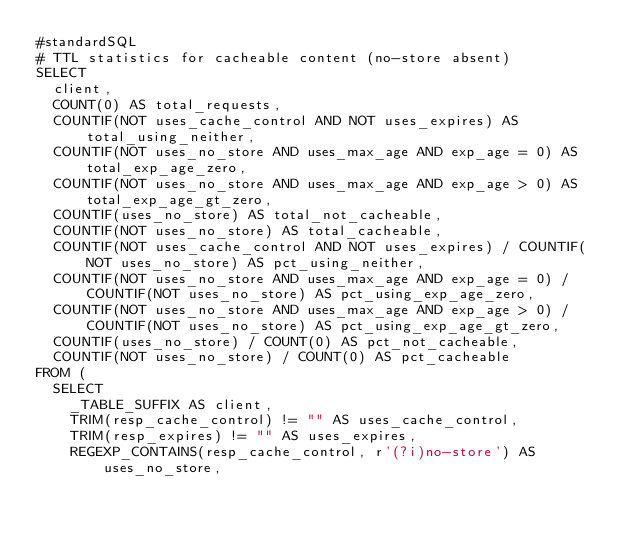<code> <loc_0><loc_0><loc_500><loc_500><_SQL_>#standardSQL
# TTL statistics for cacheable content (no-store absent)
SELECT
  client,
  COUNT(0) AS total_requests,
  COUNTIF(NOT uses_cache_control AND NOT uses_expires) AS total_using_neither,
  COUNTIF(NOT uses_no_store AND uses_max_age AND exp_age = 0) AS total_exp_age_zero,
  COUNTIF(NOT uses_no_store AND uses_max_age AND exp_age > 0) AS total_exp_age_gt_zero,
  COUNTIF(uses_no_store) AS total_not_cacheable,
  COUNTIF(NOT uses_no_store) AS total_cacheable,
  COUNTIF(NOT uses_cache_control AND NOT uses_expires) / COUNTIF(NOT uses_no_store) AS pct_using_neither,
  COUNTIF(NOT uses_no_store AND uses_max_age AND exp_age = 0) / COUNTIF(NOT uses_no_store) AS pct_using_exp_age_zero,
  COUNTIF(NOT uses_no_store AND uses_max_age AND exp_age > 0) / COUNTIF(NOT uses_no_store) AS pct_using_exp_age_gt_zero,
  COUNTIF(uses_no_store) / COUNT(0) AS pct_not_cacheable,
  COUNTIF(NOT uses_no_store) / COUNT(0) AS pct_cacheable
FROM (
  SELECT
    _TABLE_SUFFIX AS client,
    TRIM(resp_cache_control) != "" AS uses_cache_control,
    TRIM(resp_expires) != "" AS uses_expires,
    REGEXP_CONTAINS(resp_cache_control, r'(?i)no-store') AS uses_no_store,</code> 